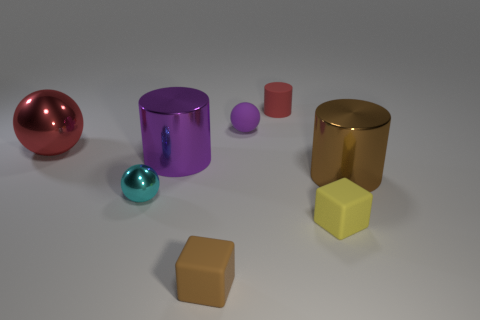There is a cylinder that is to the left of the red matte thing; is its color the same as the rubber sphere?
Give a very brief answer. Yes. Are there fewer small brown rubber blocks that are left of the tiny cyan metallic thing than big red objects?
Offer a very short reply. Yes. There is a ball that is the same material as the tiny cylinder; what color is it?
Provide a short and direct response. Purple. There is a brown thing on the left side of the red rubber object; what is its size?
Make the answer very short. Small. Do the tiny yellow block and the big red object have the same material?
Your answer should be compact. No. Is there a small purple sphere behind the small ball left of the large metallic cylinder that is to the left of the brown shiny object?
Provide a short and direct response. Yes. What is the color of the big sphere?
Offer a very short reply. Red. There is a rubber cylinder that is the same size as the cyan object; what is its color?
Give a very brief answer. Red. Do the red thing on the left side of the cyan shiny object and the small cyan object have the same shape?
Provide a short and direct response. Yes. What is the color of the large metallic cylinder on the left side of the brown object that is in front of the cylinder in front of the purple metallic cylinder?
Make the answer very short. Purple. 